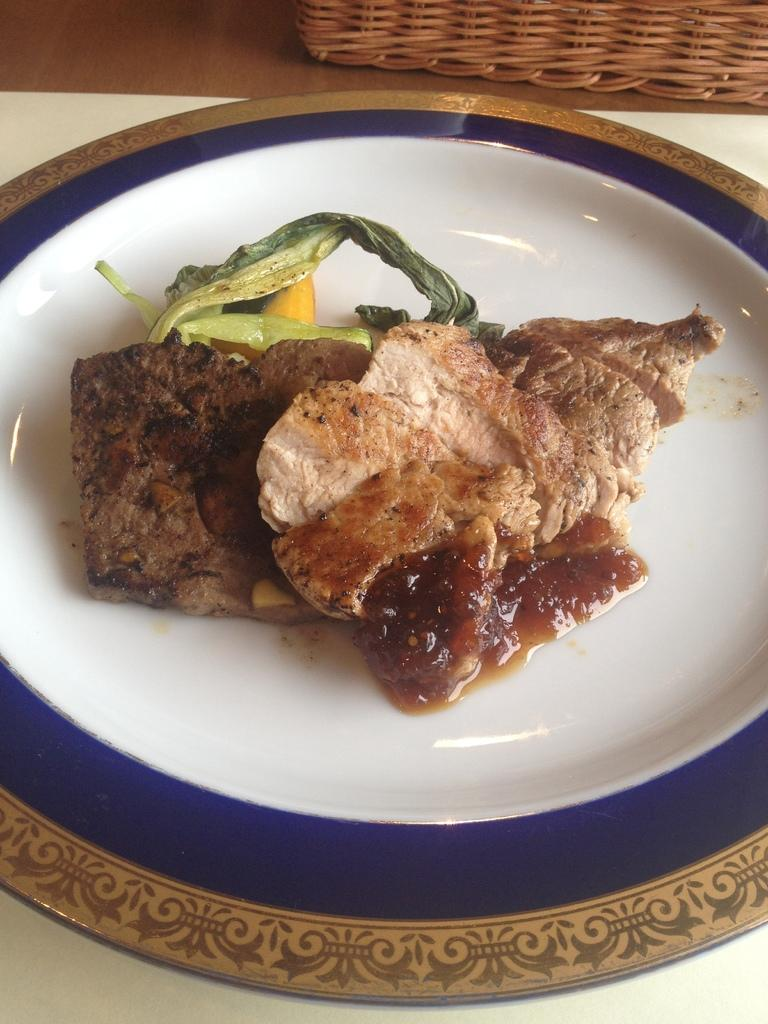What is on the plate in the image? There are food items on a plate in the image. Can you describe the object on the wooden surface? Unfortunately, the facts provided do not give enough information to describe the object on the wooden surface. What type of sheet is covering the food items in the image? There is no sheet covering the food items in the image; they are visible on the plate. 